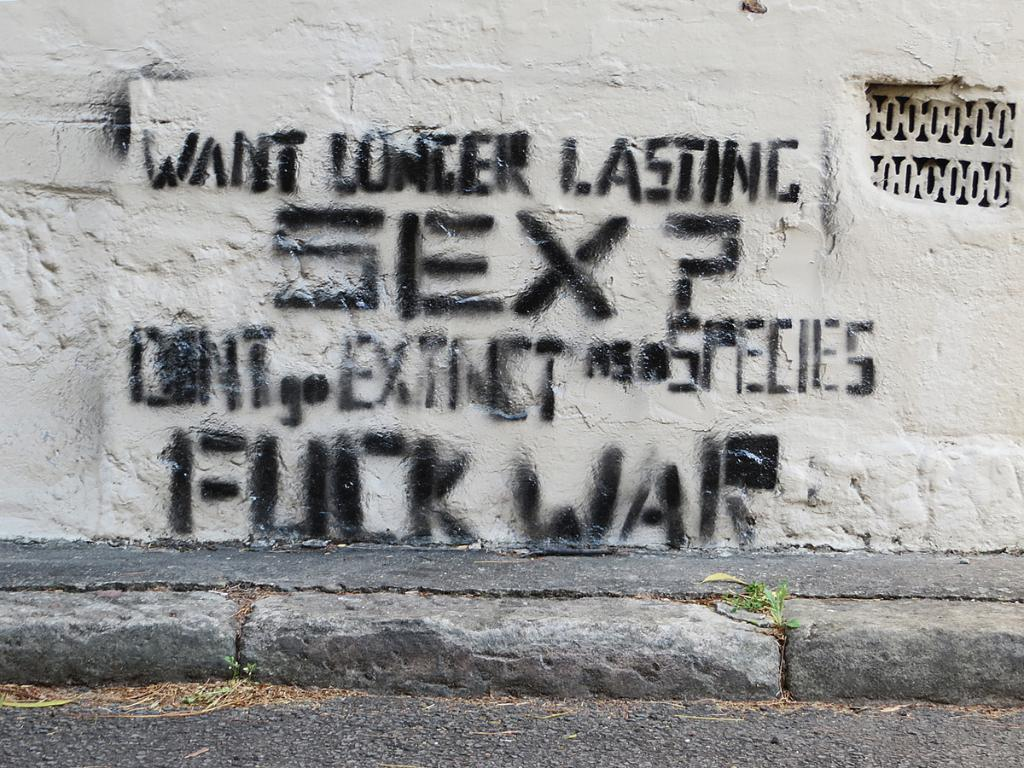What is written or displayed on the wall in the image? There is text on the wall in the image. What type of transportation route can be seen in the image? There is a road visible in the image. Is there a separate path for pedestrians in the image? Yes, there is a footpath in the image. Can you see the friend's boat in the image? There is no boat or friend present in the image. How many sons are visible in the image? There are no sons present in the image. 